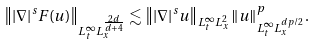Convert formula to latex. <formula><loc_0><loc_0><loc_500><loc_500>\left \| | \nabla | ^ { s } F ( u ) \right \| _ { L _ { t } ^ { \infty } L _ { x } ^ { \frac { 2 d } { d + 4 } } } & \lesssim \left \| | \nabla | ^ { s } u \right \| _ { L _ { t } ^ { \infty } L _ { x } ^ { 2 } } \| u \| _ { L _ { t } ^ { \infty } L _ { x } ^ { d p / 2 } } ^ { p } .</formula> 